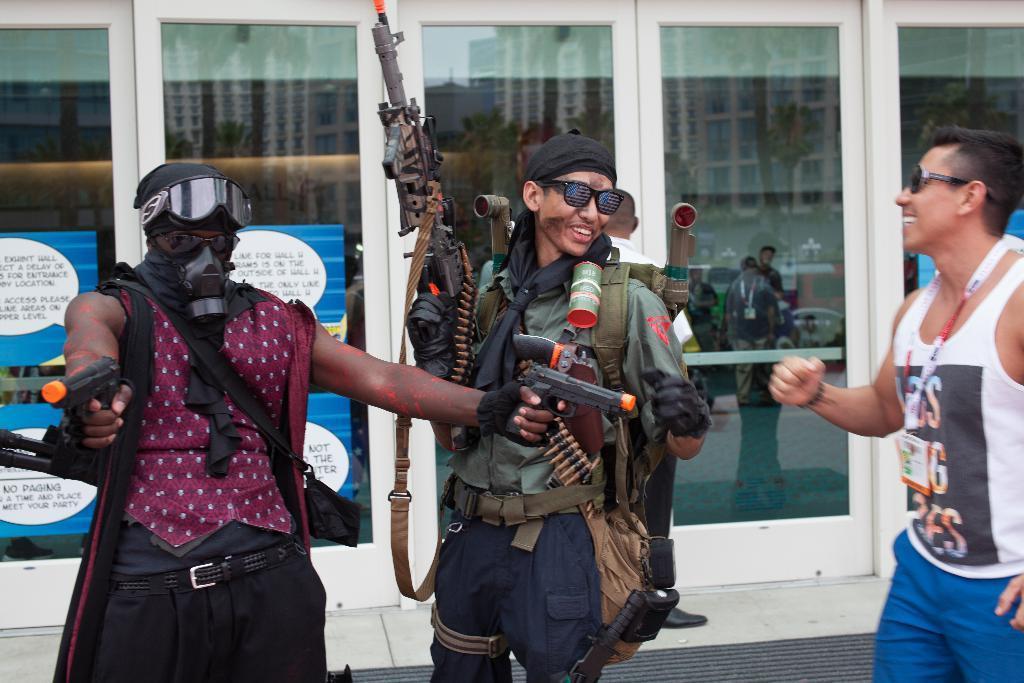Describe this image in one or two sentences. Three people standing and three are wearing spectacles and two people holding the guns and the other guy is wearing the id card. 